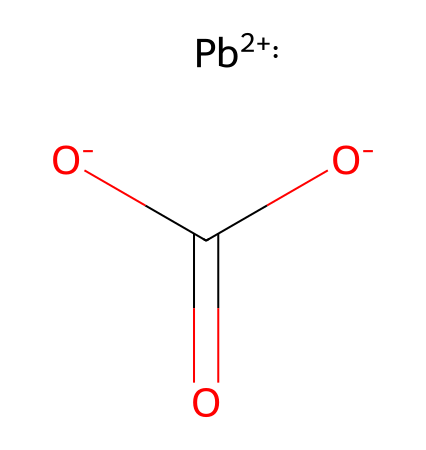what type of metal is represented in this structure? The structure contains lead (Pb), which is indicated by the presence of the lead ion (Pb+2) in the SMILES notation.
Answer: lead how many oxygen atoms are present in this chemical? The SMILES notation shows two oxygen atoms connected as negative ions ([O-]), which confirms their presence.
Answer: two what is the total charge of the chemical entity in the structure? The lead ion has a charge of +2, and the two carboxylate ions ([O-]C(=O)[O-]) have a total charge of -2, resulting in a net charge of 0 for the entire molecule.
Answer: zero which functional group can be identified in this chemical? The presence of the -COO- group indicates that a carboxylate functional group is present, characterized by the carbon atom double-bonded to one oxygen and single-bonded to another oxygen atom.
Answer: carboxylate what is the likely use of this metal in artworks? Lead is often used in pigments due to its opacity and strong coloring properties, particularly in historical art materials.
Answer: pigments how does the oxidation state of lead influence its properties in this compound? In this structure, the lead has an oxidation state of +2, which affects its reactivity and stability, allowing it to form stable complexes with the carboxylate group.
Answer: oxidation state +2 what safety concerns are associated with using this metal in art? Lead is toxic and poses serious health risks, including lead poisoning, which is a primary concern when used in art materials.
Answer: toxicity 